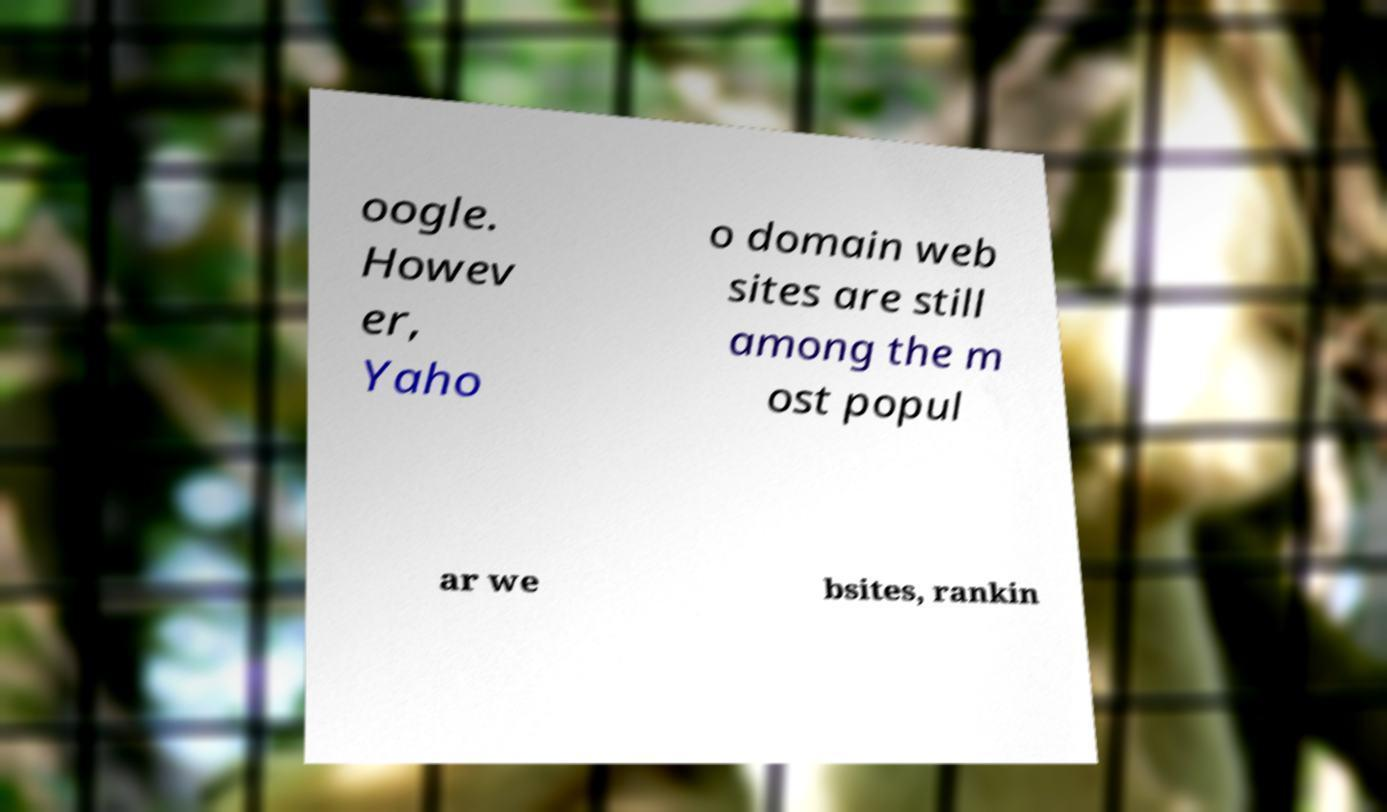Could you assist in decoding the text presented in this image and type it out clearly? oogle. Howev er, Yaho o domain web sites are still among the m ost popul ar we bsites, rankin 